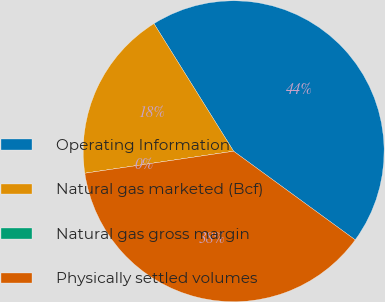Convert chart. <chart><loc_0><loc_0><loc_500><loc_500><pie_chart><fcel>Operating Information<fcel>Natural gas marketed (Bcf)<fcel>Natural gas gross margin<fcel>Physically settled volumes<nl><fcel>43.91%<fcel>18.45%<fcel>0.0%<fcel>37.64%<nl></chart> 